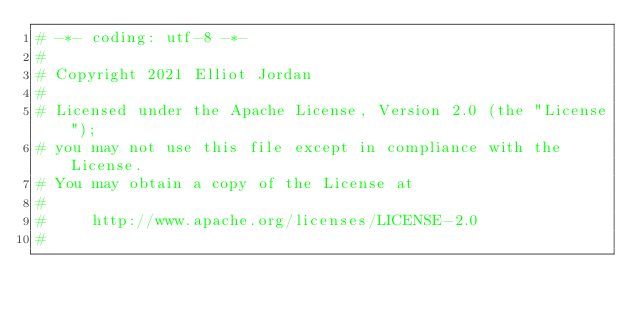Convert code to text. <code><loc_0><loc_0><loc_500><loc_500><_Python_># -*- coding: utf-8 -*-
#
# Copyright 2021 Elliot Jordan
#
# Licensed under the Apache License, Version 2.0 (the "License");
# you may not use this file except in compliance with the License.
# You may obtain a copy of the License at
#
#     http://www.apache.org/licenses/LICENSE-2.0
#</code> 